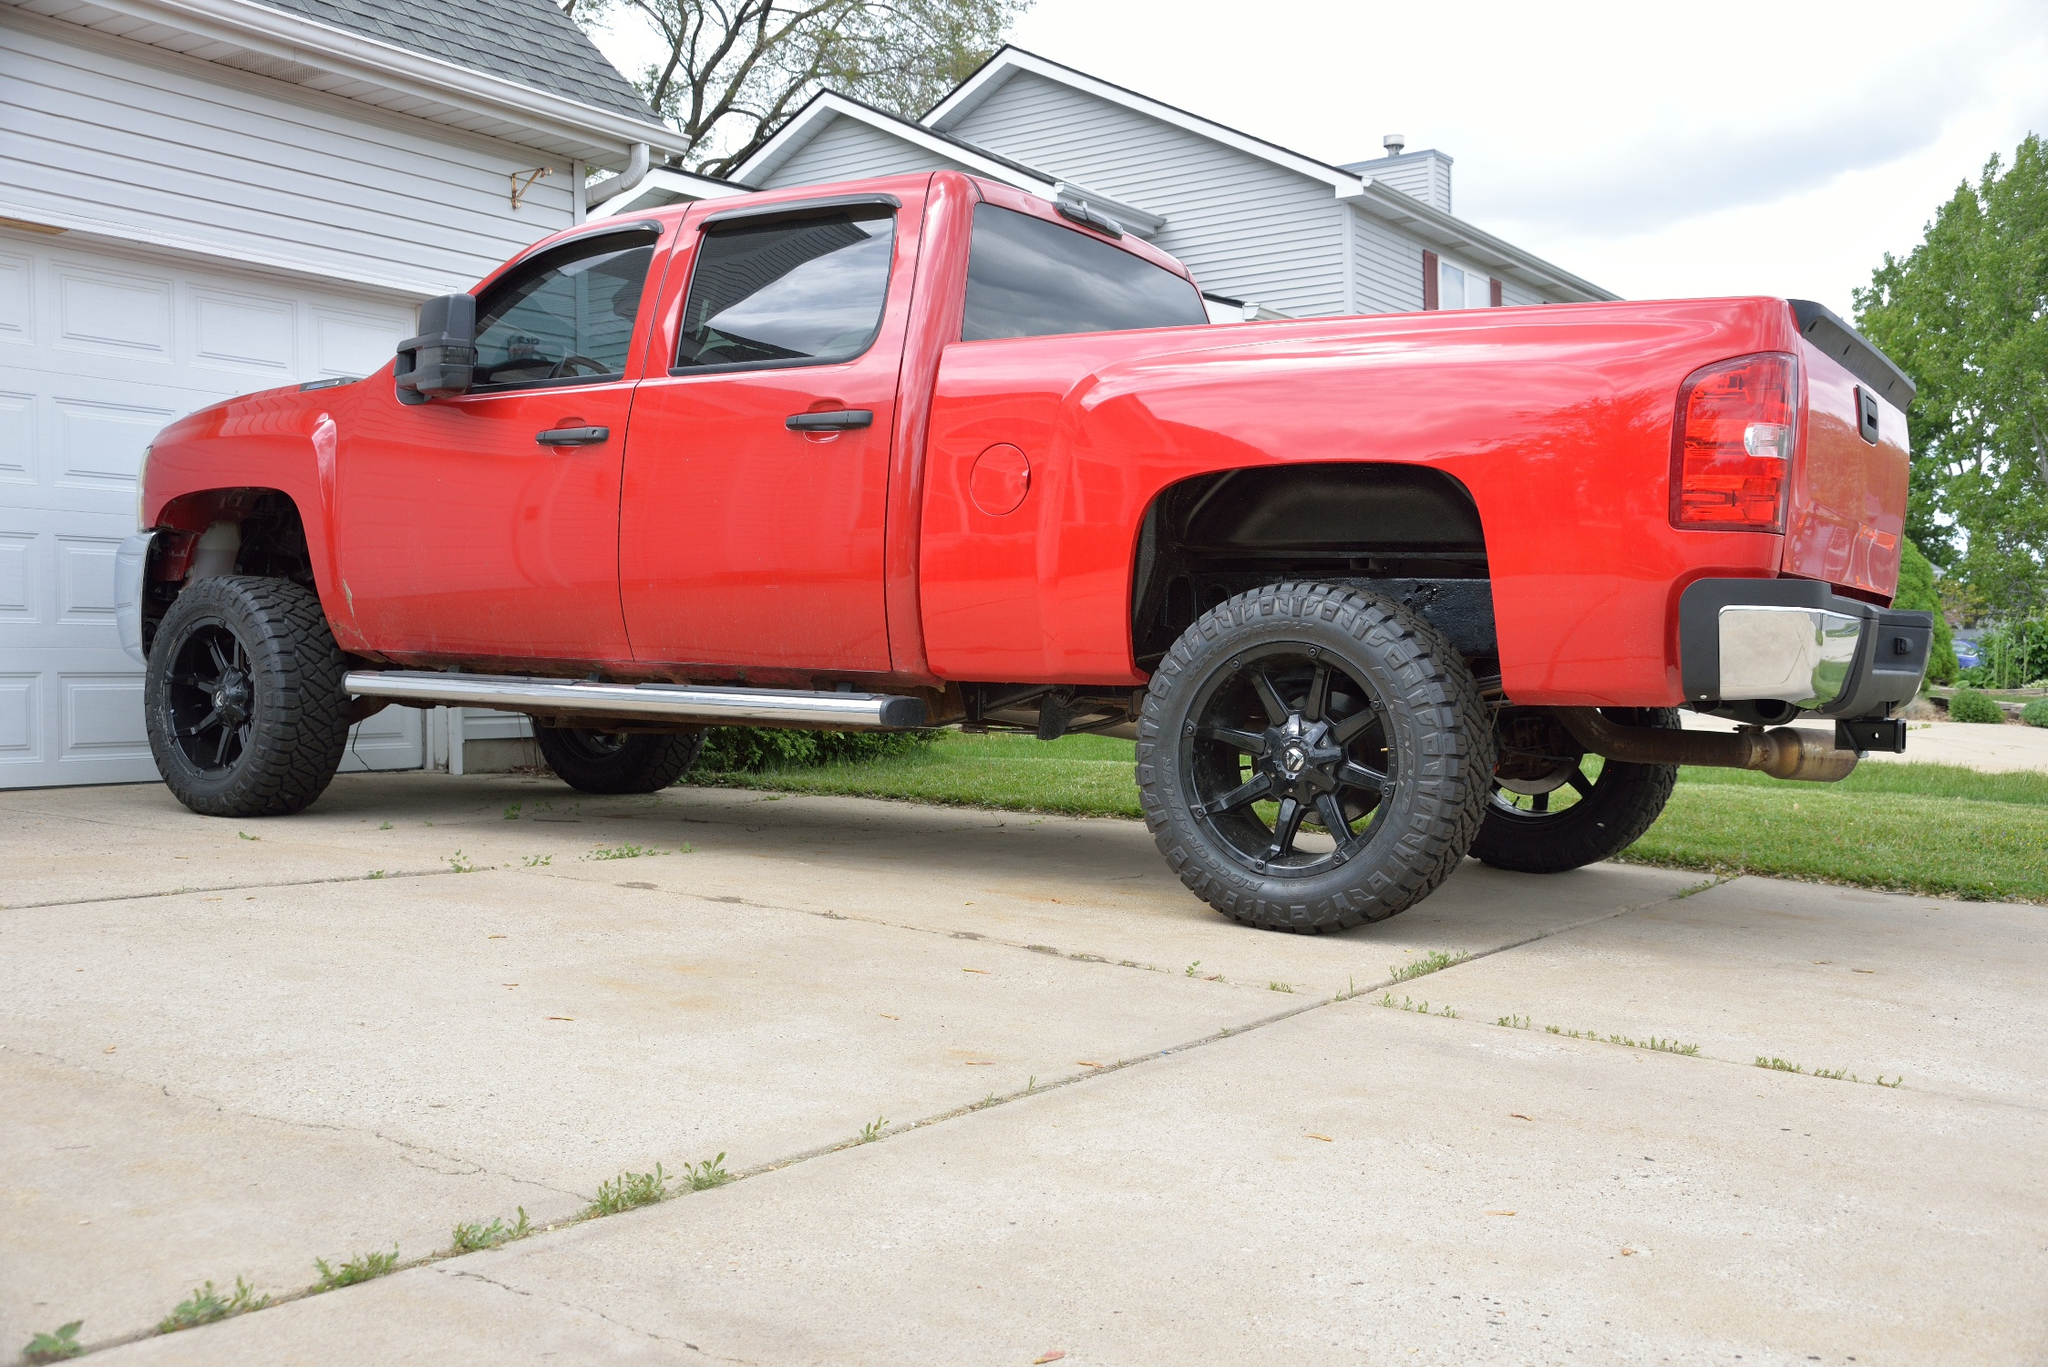Can you describe the main features of this image for me? The image presents a vivid red pickup truck, notable for its heightened stance above striking black rims and hefty tires, suggesting robustness and power. Parked on a concrete driveway, the truck is parallel to a pristine white garage door, hinting at meticulous upkeep. The backdrop features a suburban home painted in a soft gray, complementing the truck’s vibrant hue. A neatly maintained green lawn extends to the left, enhancing the suburban aesthetic. The sky overhead is bright blue with delicate, wispy clouds, contributing to a serene suburban morning ambiance. This scene not only captures the vehicle's bold aesthetics but also a glimpse into suburban life, possibly reflecting the owner's pride and care. 